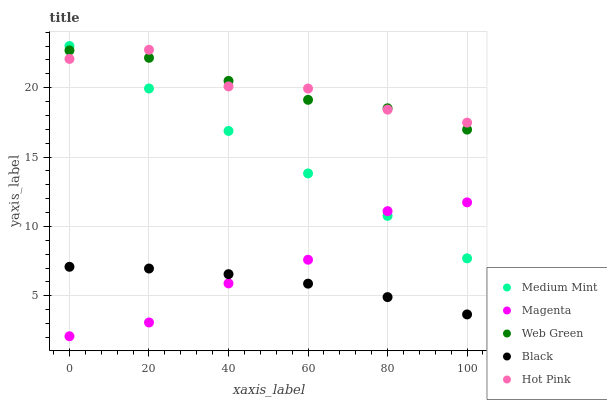Does Black have the minimum area under the curve?
Answer yes or no. Yes. Does Hot Pink have the maximum area under the curve?
Answer yes or no. Yes. Does Magenta have the minimum area under the curve?
Answer yes or no. No. Does Magenta have the maximum area under the curve?
Answer yes or no. No. Is Medium Mint the smoothest?
Answer yes or no. Yes. Is Hot Pink the roughest?
Answer yes or no. Yes. Is Magenta the smoothest?
Answer yes or no. No. Is Magenta the roughest?
Answer yes or no. No. Does Magenta have the lowest value?
Answer yes or no. Yes. Does Hot Pink have the lowest value?
Answer yes or no. No. Does Medium Mint have the highest value?
Answer yes or no. Yes. Does Magenta have the highest value?
Answer yes or no. No. Is Magenta less than Hot Pink?
Answer yes or no. Yes. Is Web Green greater than Black?
Answer yes or no. Yes. Does Medium Mint intersect Hot Pink?
Answer yes or no. Yes. Is Medium Mint less than Hot Pink?
Answer yes or no. No. Is Medium Mint greater than Hot Pink?
Answer yes or no. No. Does Magenta intersect Hot Pink?
Answer yes or no. No. 